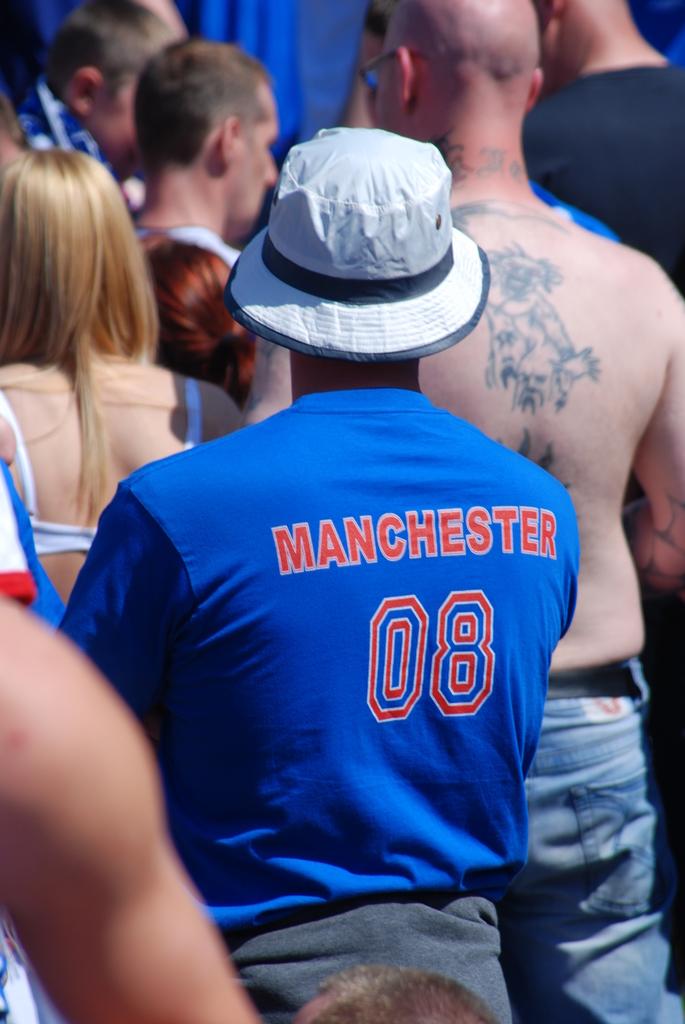What is the name printed on the man's blue shirt?
Your response must be concise. Manchester. What number is shown?
Your answer should be very brief. 08. 